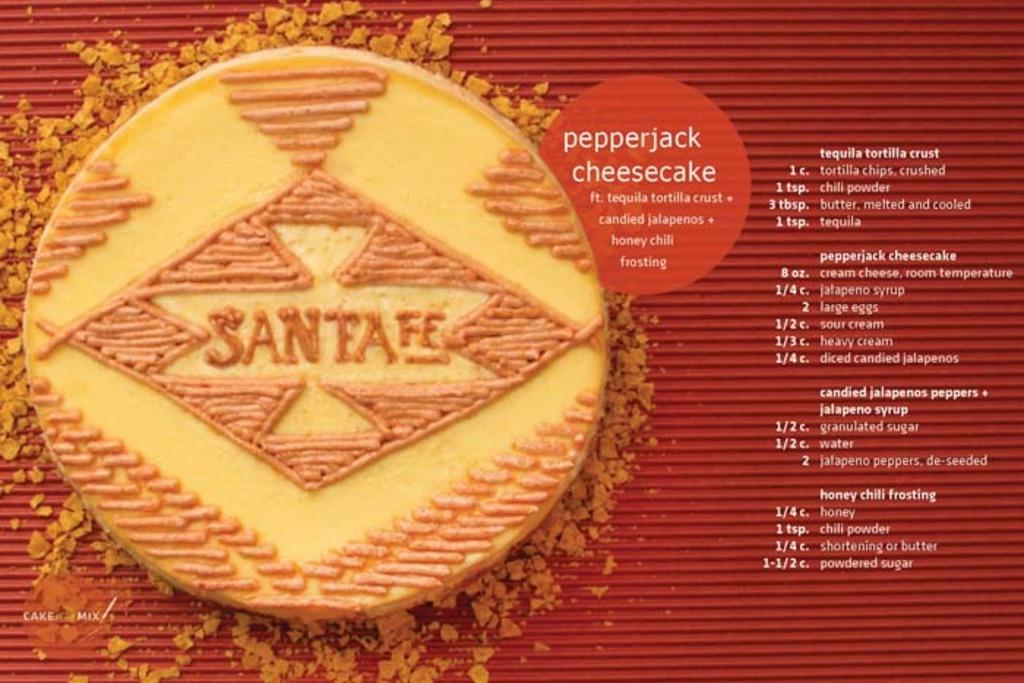What is the main object in the image? There is a menu in the image. What can be seen on the menu besides text? The menu has an image of a food item. What information is provided on the menu? There is text written on the menu. Are there any visible imperfections on the menu? Yes, there are water marks visible in the image. Can you tell me how many bushes are depicted on the menu? There are no bushes depicted on the menu; it only contains text and an image of a food item. Is there a swing visible in the image? No, there is no swing present in the image; it only features a menu with an image of a food item and text. 